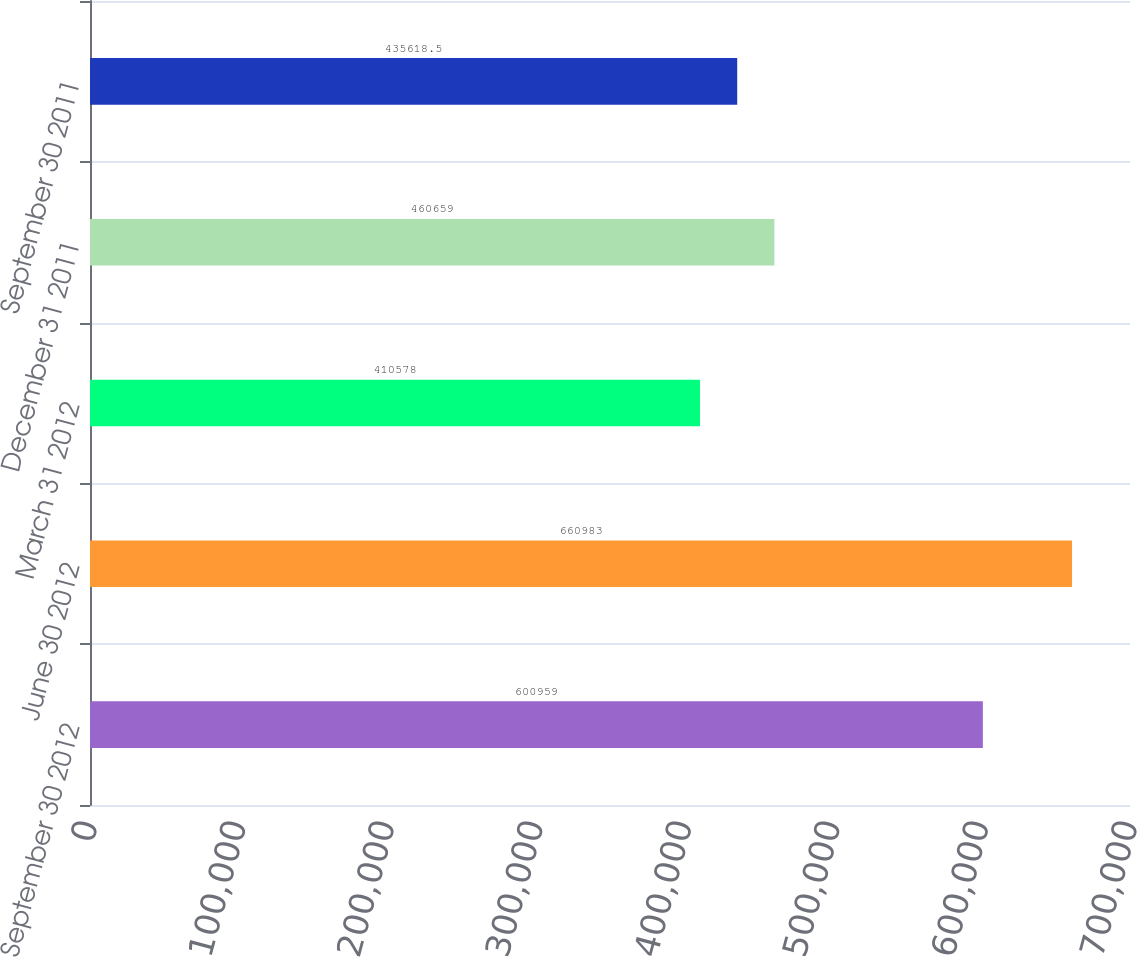Convert chart to OTSL. <chart><loc_0><loc_0><loc_500><loc_500><bar_chart><fcel>September 30 2012<fcel>June 30 2012<fcel>March 31 2012<fcel>December 31 2011<fcel>September 30 2011<nl><fcel>600959<fcel>660983<fcel>410578<fcel>460659<fcel>435618<nl></chart> 